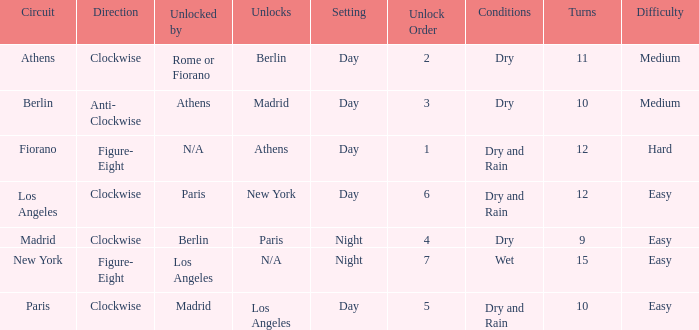How many instances is the unlocked n/a? 1.0. 